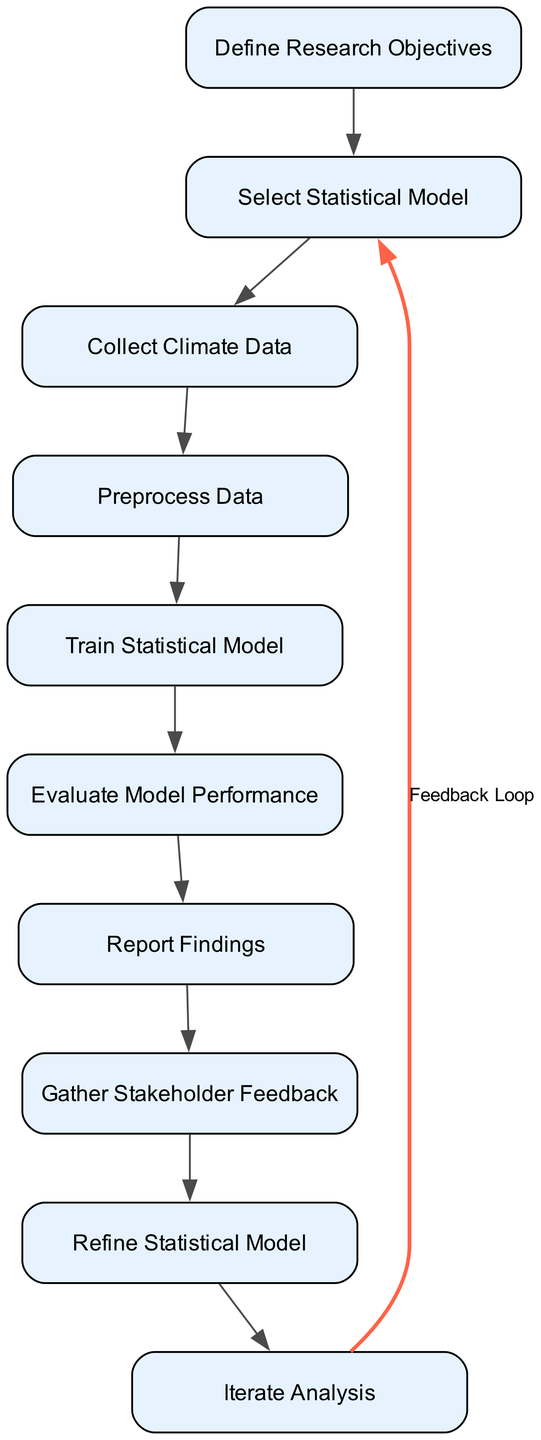What is the first node in the sequence? The first node, based on the sequence, is "Define Research Objectives." This is the initial step in the flow where the goals for the climate data analysis are established.
Answer: Define Research Objectives How many nodes are present in the diagram? Counting all the nodes listed in the diagram, there are a total of ten distinct nodes that represent various stages of the feedback loop for assessing statistical models.
Answer: 10 What action follows "Gather Stakeholder Feedback"? The action that follows "Gather Stakeholder Feedback" is "Refine Statistical Model." This indicates the step where adjustments to the model are made based on received feedback.
Answer: Refine Statistical Model What is the relationship between "Select Statistical Model" and "Preprocess Data"? The relationship is sequential; "Select Statistical Model" precedes "Preprocess Data," indicating that the selection of a model must occur before data preprocessing can take place.
Answer: Sequential What does the feedback loop connect to in the diagram? The feedback loop connects from "Iterate Analysis" back to "Define Research Objectives." This indicates that after analyzing the refined model, the research objectives may be revisited.
Answer: Define Research Objectives How many distinct actions are indicated in the feedback loop? The feedback loop encompasses one distinct action, which is "Refine Statistical Model." This action indicates that model adjustments are made based on the feedback loop's input.
Answer: 1 What is the last node in the sequence? The last node in the sequence is "Report Findings," which implies the documentation of results and insights following the entire analysis process.
Answer: Report Findings What is the key purpose of the "Evaluate Model Performance" step? The key purpose of this step is to assess the accuracy and reliability of the trained statistical model, ensuring that its predictions are valid for the analysis.
Answer: Assess accuracy and reliability 